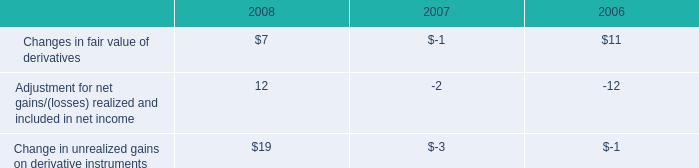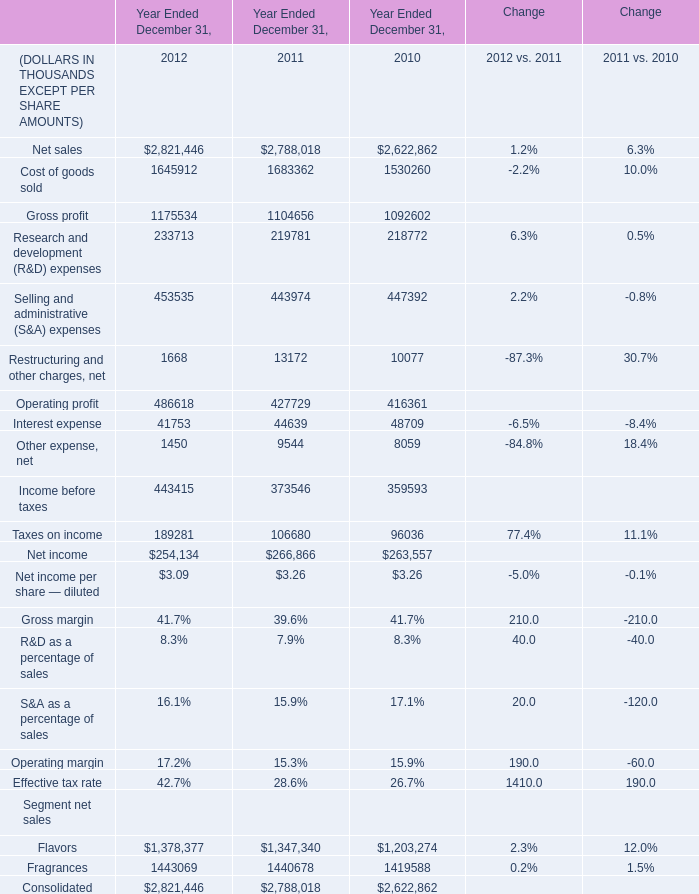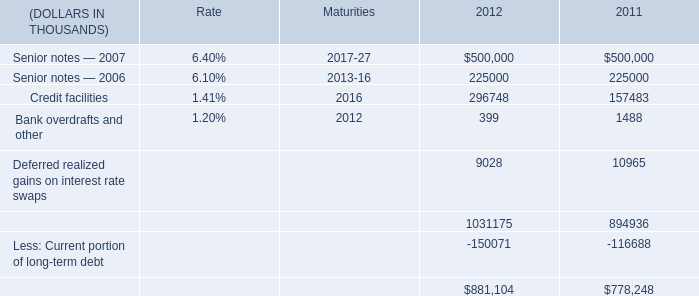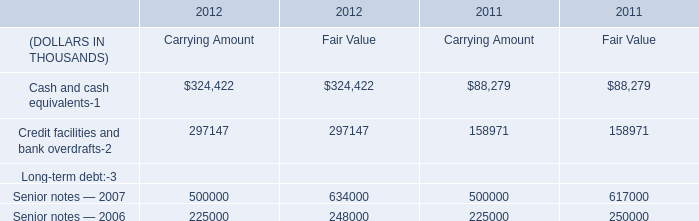What is the average amount of Flavors Segment net sales of Year Ended December 31, 2012, and Senior notes — 2006 of Maturities ? 
Computations: ((1378377.0 + 201316.0) / 2)
Answer: 789846.5. 